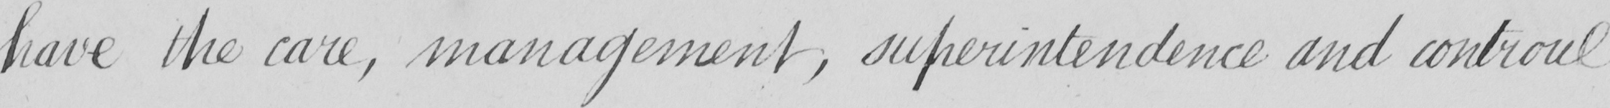Can you tell me what this handwritten text says? have the care , management , superintendence and controul 